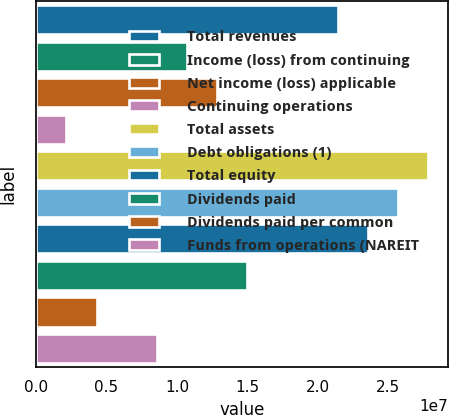<chart> <loc_0><loc_0><loc_500><loc_500><bar_chart><fcel>Total revenues<fcel>Income (loss) from continuing<fcel>Net income (loss) applicable<fcel>Continuing operations<fcel>Total assets<fcel>Debt obligations (1)<fcel>Total equity<fcel>Dividends paid<fcel>Dividends paid per common<fcel>Funds from operations (NAREIT<nl><fcel>2.14498e+07<fcel>1.07249e+07<fcel>1.28699e+07<fcel>2.14498e+06<fcel>2.78848e+07<fcel>2.57398e+07<fcel>2.35948e+07<fcel>1.50149e+07<fcel>4.28997e+06<fcel>8.57994e+06<nl></chart> 